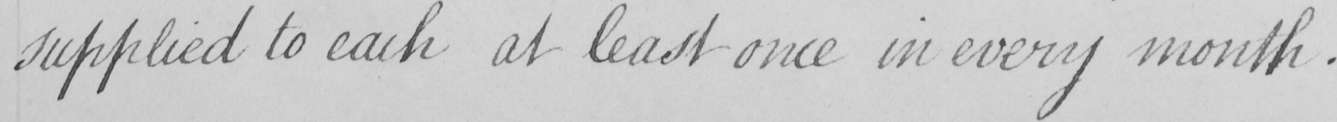What text is written in this handwritten line? supplied to each at least once in every month . 